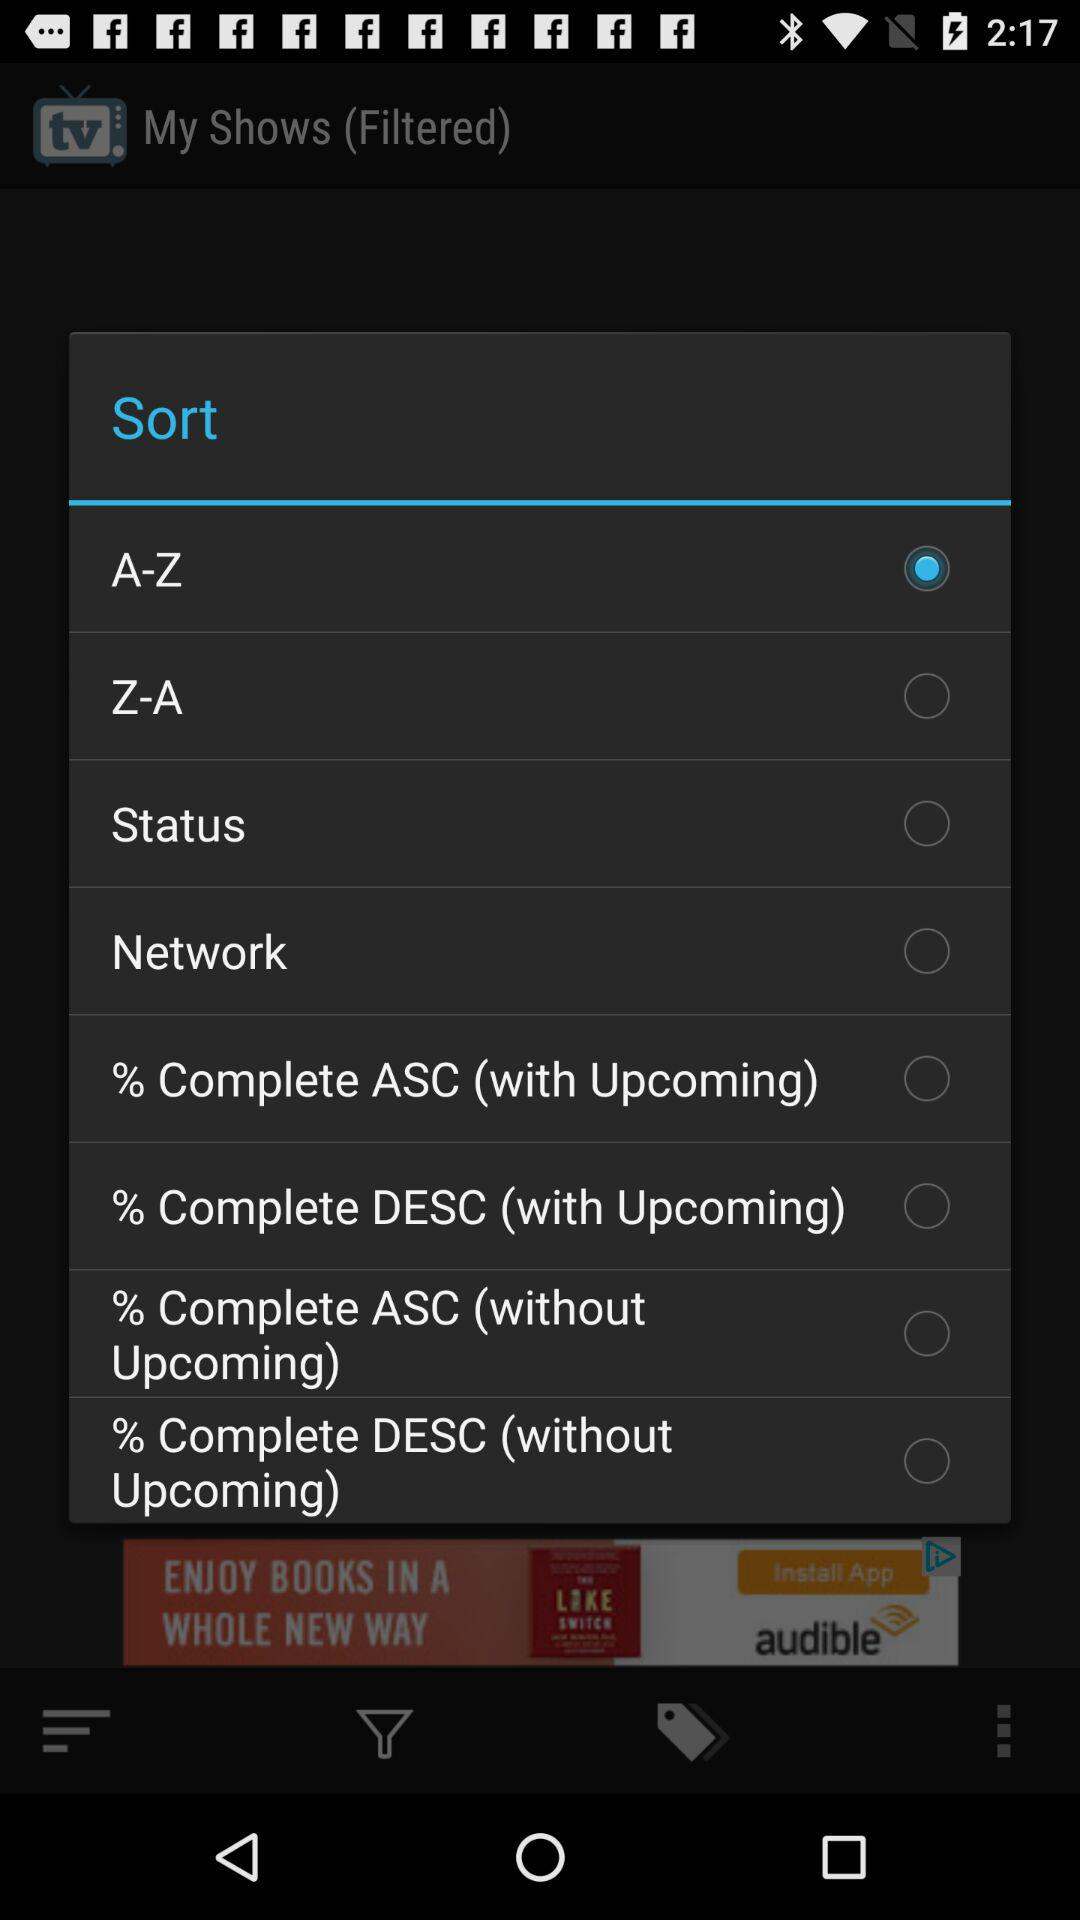Which option is selected? The selected option is "A-Z". 